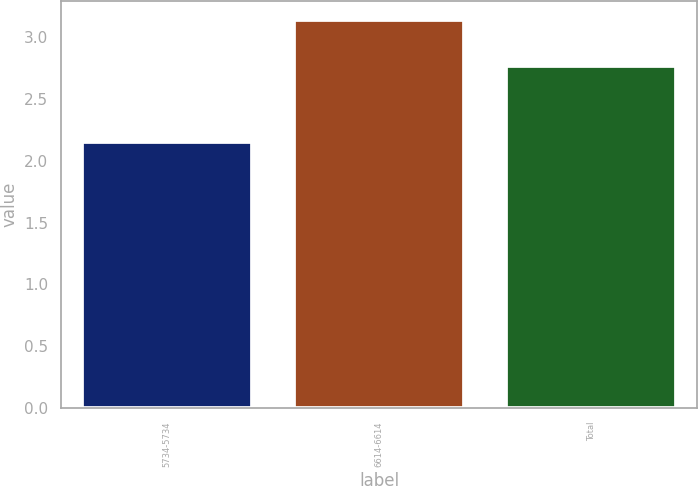Convert chart. <chart><loc_0><loc_0><loc_500><loc_500><bar_chart><fcel>5734-5734<fcel>6614-6614<fcel>Total<nl><fcel>2.15<fcel>3.14<fcel>2.77<nl></chart> 